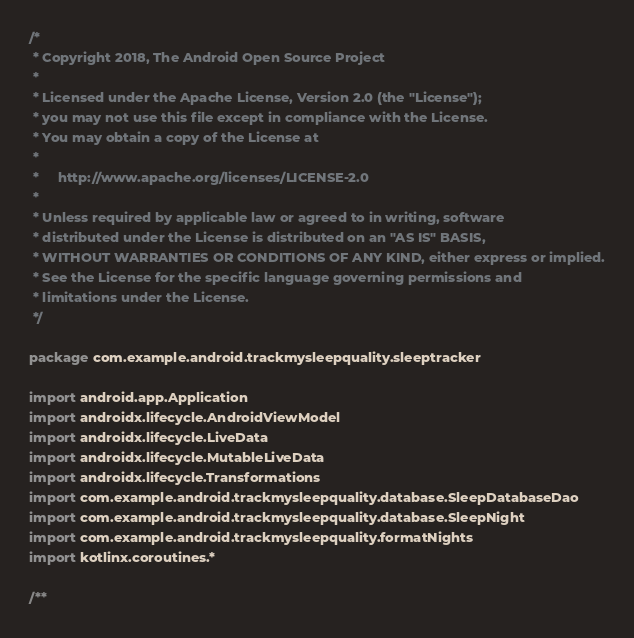<code> <loc_0><loc_0><loc_500><loc_500><_Kotlin_>/*
 * Copyright 2018, The Android Open Source Project
 *
 * Licensed under the Apache License, Version 2.0 (the "License");
 * you may not use this file except in compliance with the License.
 * You may obtain a copy of the License at
 *
 *     http://www.apache.org/licenses/LICENSE-2.0
 *
 * Unless required by applicable law or agreed to in writing, software
 * distributed under the License is distributed on an "AS IS" BASIS,
 * WITHOUT WARRANTIES OR CONDITIONS OF ANY KIND, either express or implied.
 * See the License for the specific language governing permissions and
 * limitations under the License.
 */

package com.example.android.trackmysleepquality.sleeptracker

import android.app.Application
import androidx.lifecycle.AndroidViewModel
import androidx.lifecycle.LiveData
import androidx.lifecycle.MutableLiveData
import androidx.lifecycle.Transformations
import com.example.android.trackmysleepquality.database.SleepDatabaseDao
import com.example.android.trackmysleepquality.database.SleepNight
import com.example.android.trackmysleepquality.formatNights
import kotlinx.coroutines.*

/**</code> 